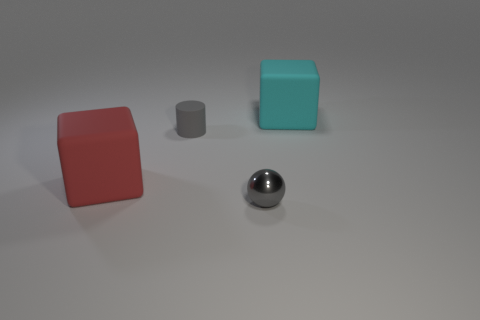What material is the object that is the same color as the small shiny ball?
Your response must be concise. Rubber. There is a large rubber block in front of the cube behind the tiny gray rubber object; is there a tiny gray shiny ball that is to the right of it?
Provide a short and direct response. Yes. Is the number of gray shiny spheres right of the gray ball less than the number of large rubber objects that are on the right side of the tiny gray cylinder?
Your response must be concise. Yes. There is a large cube that is made of the same material as the big red object; what is its color?
Your response must be concise. Cyan. What is the color of the big matte object that is in front of the cube behind the gray matte thing?
Keep it short and to the point. Red. Are there any other tiny objects that have the same color as the small matte object?
Offer a very short reply. Yes. There is a rubber thing that is the same size as the red matte cube; what is its shape?
Offer a very short reply. Cube. There is a rubber cube that is to the right of the big red cube; how many big cyan cubes are behind it?
Make the answer very short. 0. Is the color of the metallic object the same as the tiny matte object?
Give a very brief answer. Yes. How many other objects are the same material as the sphere?
Ensure brevity in your answer.  0. 